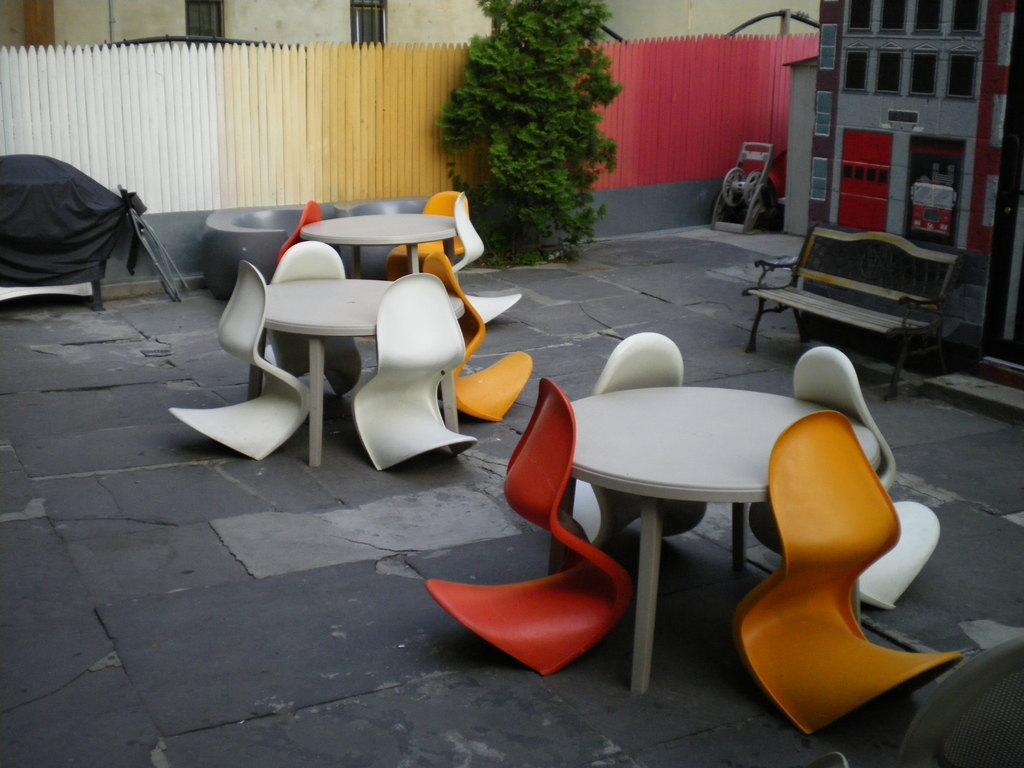Please provide a concise description of this image. In this picture, we see three tables and chairs in white, yellow and red color. On the right side, we see a grey color building. Beside that, we see a machinery equipment. We even see a bench. On the left side, we see a bench which is covered with black color sheet. Beside that, we see a grey color thing which looks like a tub. Beside that, we see a tree. Behind that, we see the picket fence in white, yellow and red color. In the background, we see a building. 